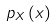Convert formula to latex. <formula><loc_0><loc_0><loc_500><loc_500>p _ { X } \left ( x \right )</formula> 